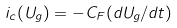Convert formula to latex. <formula><loc_0><loc_0><loc_500><loc_500>i _ { c } ( U _ { g } ) = - C _ { F } ( d U _ { g } / d t )</formula> 